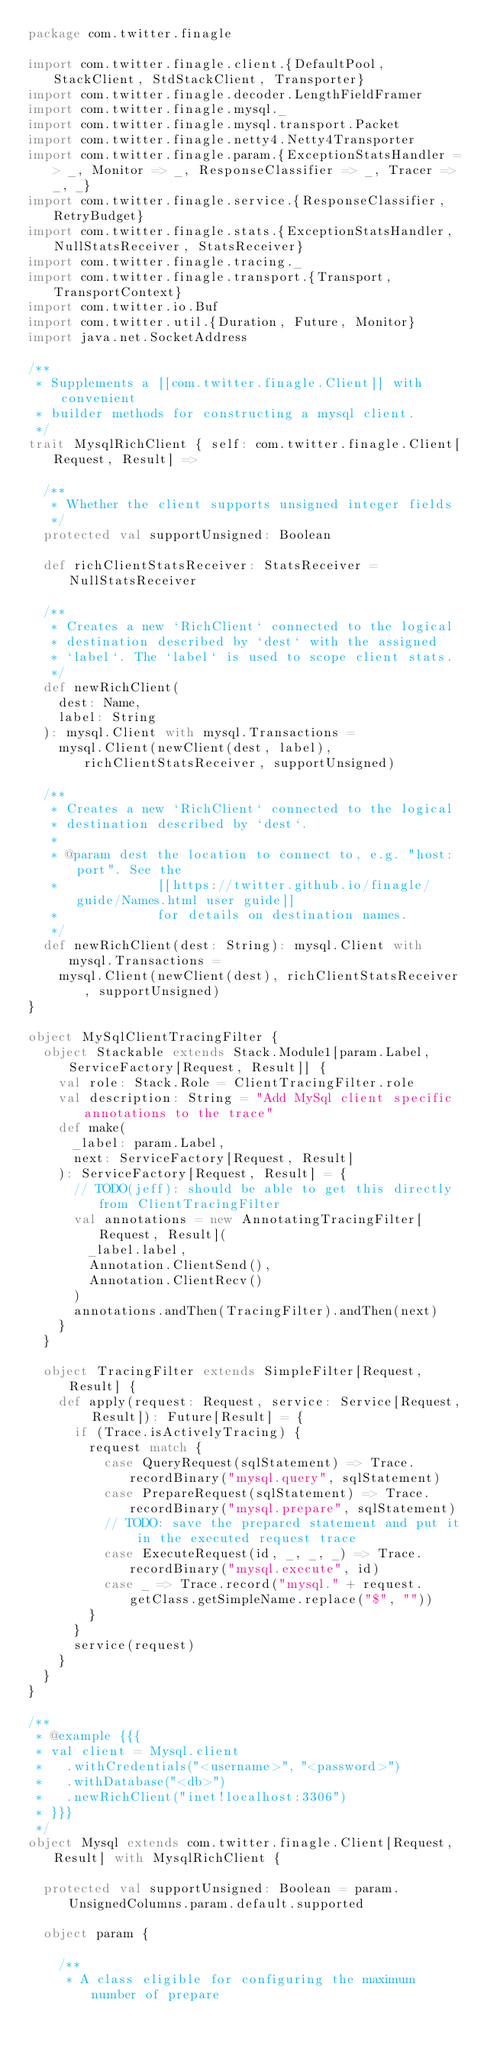<code> <loc_0><loc_0><loc_500><loc_500><_Scala_>package com.twitter.finagle

import com.twitter.finagle.client.{DefaultPool, StackClient, StdStackClient, Transporter}
import com.twitter.finagle.decoder.LengthFieldFramer
import com.twitter.finagle.mysql._
import com.twitter.finagle.mysql.transport.Packet
import com.twitter.finagle.netty4.Netty4Transporter
import com.twitter.finagle.param.{ExceptionStatsHandler => _, Monitor => _, ResponseClassifier => _, Tracer => _, _}
import com.twitter.finagle.service.{ResponseClassifier, RetryBudget}
import com.twitter.finagle.stats.{ExceptionStatsHandler, NullStatsReceiver, StatsReceiver}
import com.twitter.finagle.tracing._
import com.twitter.finagle.transport.{Transport, TransportContext}
import com.twitter.io.Buf
import com.twitter.util.{Duration, Future, Monitor}
import java.net.SocketAddress

/**
 * Supplements a [[com.twitter.finagle.Client]] with convenient
 * builder methods for constructing a mysql client.
 */
trait MysqlRichClient { self: com.twitter.finagle.Client[Request, Result] =>

  /**
   * Whether the client supports unsigned integer fields
   */
  protected val supportUnsigned: Boolean

  def richClientStatsReceiver: StatsReceiver = NullStatsReceiver

  /**
   * Creates a new `RichClient` connected to the logical
   * destination described by `dest` with the assigned
   * `label`. The `label` is used to scope client stats.
   */
  def newRichClient(
    dest: Name,
    label: String
  ): mysql.Client with mysql.Transactions =
    mysql.Client(newClient(dest, label), richClientStatsReceiver, supportUnsigned)

  /**
   * Creates a new `RichClient` connected to the logical
   * destination described by `dest`.
   *
   * @param dest the location to connect to, e.g. "host:port". See the
   *             [[https://twitter.github.io/finagle/guide/Names.html user guide]]
   *             for details on destination names.
   */
  def newRichClient(dest: String): mysql.Client with mysql.Transactions =
    mysql.Client(newClient(dest), richClientStatsReceiver, supportUnsigned)
}

object MySqlClientTracingFilter {
  object Stackable extends Stack.Module1[param.Label, ServiceFactory[Request, Result]] {
    val role: Stack.Role = ClientTracingFilter.role
    val description: String = "Add MySql client specific annotations to the trace"
    def make(
      _label: param.Label,
      next: ServiceFactory[Request, Result]
    ): ServiceFactory[Request, Result] = {
      // TODO(jeff): should be able to get this directly from ClientTracingFilter
      val annotations = new AnnotatingTracingFilter[Request, Result](
        _label.label,
        Annotation.ClientSend(),
        Annotation.ClientRecv()
      )
      annotations.andThen(TracingFilter).andThen(next)
    }
  }

  object TracingFilter extends SimpleFilter[Request, Result] {
    def apply(request: Request, service: Service[Request, Result]): Future[Result] = {
      if (Trace.isActivelyTracing) {
        request match {
          case QueryRequest(sqlStatement) => Trace.recordBinary("mysql.query", sqlStatement)
          case PrepareRequest(sqlStatement) => Trace.recordBinary("mysql.prepare", sqlStatement)
          // TODO: save the prepared statement and put it in the executed request trace
          case ExecuteRequest(id, _, _, _) => Trace.recordBinary("mysql.execute", id)
          case _ => Trace.record("mysql." + request.getClass.getSimpleName.replace("$", ""))
        }
      }
      service(request)
    }
  }
}

/**
 * @example {{{
 * val client = Mysql.client
 *   .withCredentials("<username>", "<password>")
 *   .withDatabase("<db>")
 *   .newRichClient("inet!localhost:3306")
 * }}}
 */
object Mysql extends com.twitter.finagle.Client[Request, Result] with MysqlRichClient {

  protected val supportUnsigned: Boolean = param.UnsignedColumns.param.default.supported

  object param {

    /**
     * A class eligible for configuring the maximum number of prepare</code> 